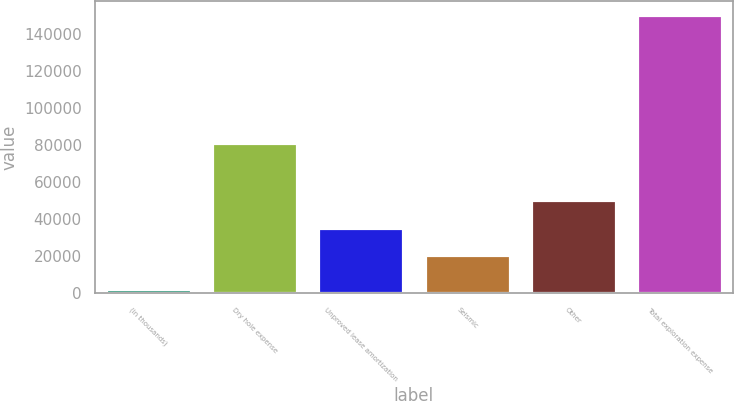<chart> <loc_0><loc_0><loc_500><loc_500><bar_chart><fcel>(in thousands)<fcel>Dry hole expense<fcel>Unproved lease amortization<fcel>Seismic<fcel>Other<fcel>Total exploration expense<nl><fcel>2002<fcel>81396<fcel>35361.9<fcel>20492<fcel>50231.8<fcel>150701<nl></chart> 